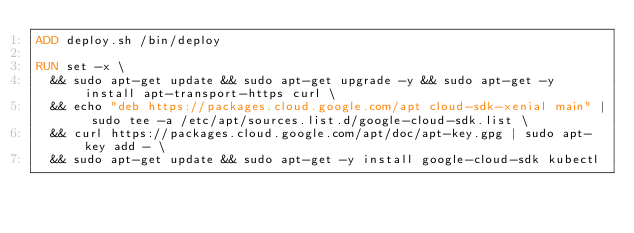<code> <loc_0><loc_0><loc_500><loc_500><_Dockerfile_>ADD deploy.sh /bin/deploy

RUN set -x \
  && sudo apt-get update && sudo apt-get upgrade -y && sudo apt-get -y install apt-transport-https curl \
  && echo "deb https://packages.cloud.google.com/apt cloud-sdk-xenial main" | sudo tee -a /etc/apt/sources.list.d/google-cloud-sdk.list \
  && curl https://packages.cloud.google.com/apt/doc/apt-key.gpg | sudo apt-key add - \
  && sudo apt-get update && sudo apt-get -y install google-cloud-sdk kubectl
</code> 